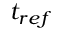<formula> <loc_0><loc_0><loc_500><loc_500>t _ { r e f }</formula> 